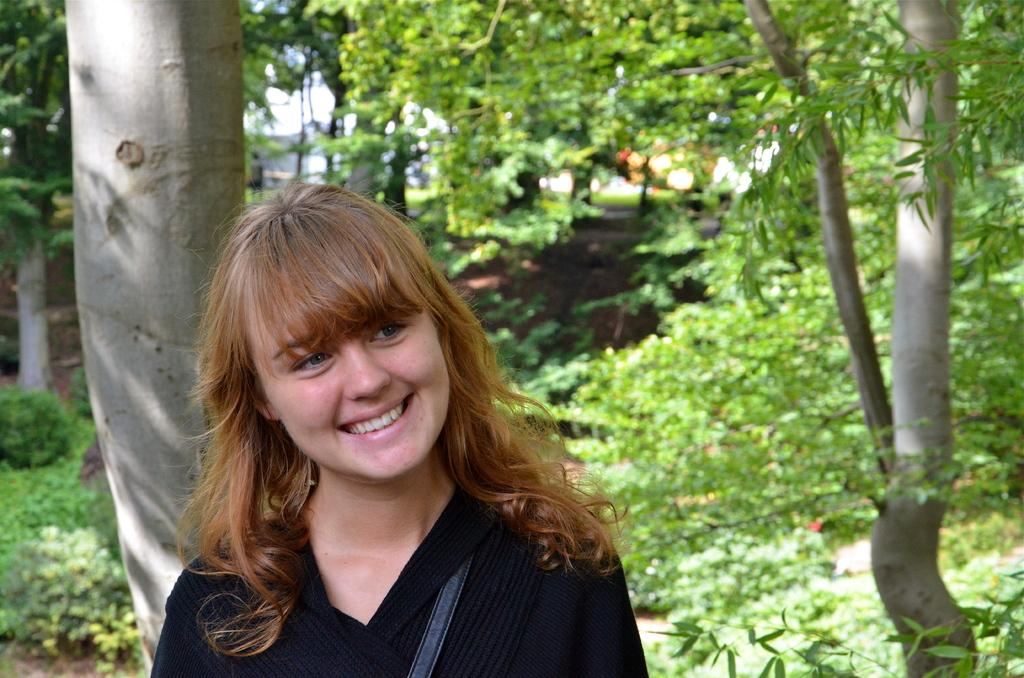Who is present in the image? There is a woman in the image. What can be seen on the tree in the image? The bark of a tree is visible in the image. What type of vegetation is present in the image? There are plants and trees in the image. What part of the natural environment is visible in the image? The sky is visible in the image. What type of account does the woman have in the image? There is no mention of an account in the image; it features a woman, bark, plants, trees, and the sky. 